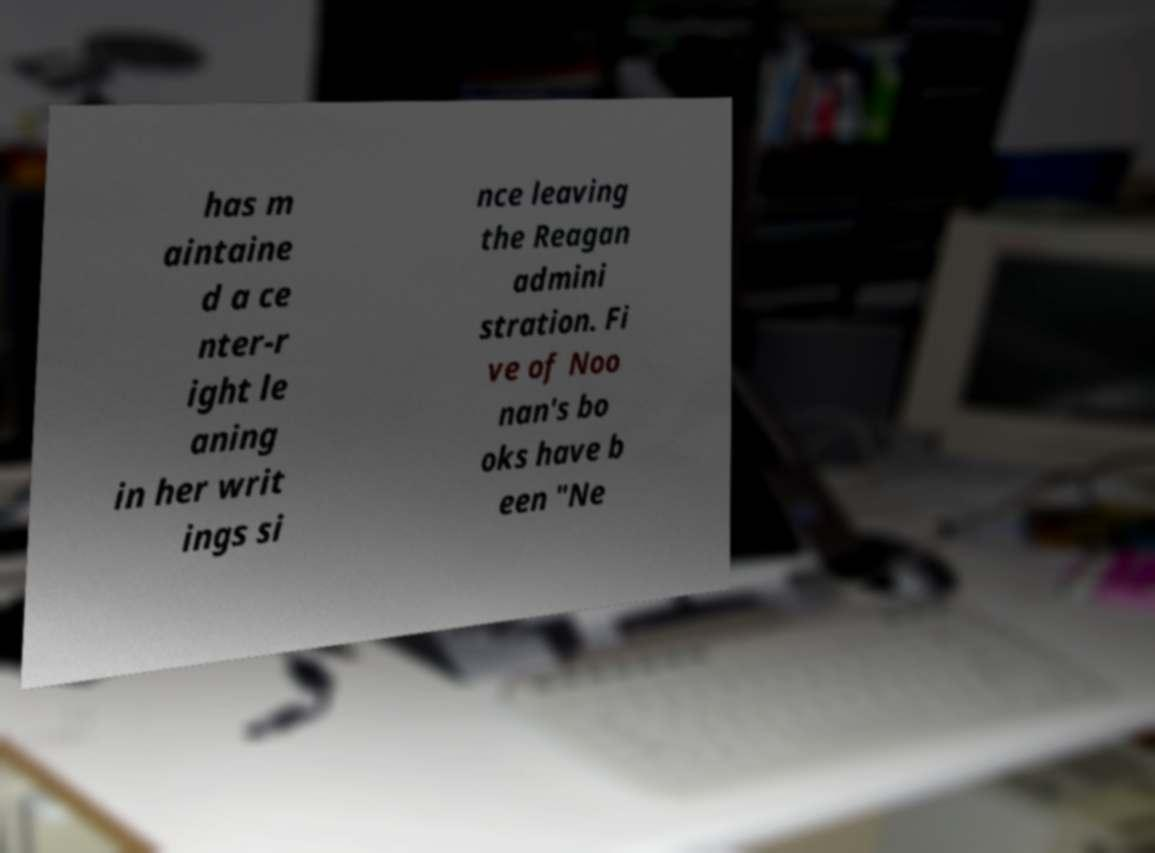Could you assist in decoding the text presented in this image and type it out clearly? has m aintaine d a ce nter-r ight le aning in her writ ings si nce leaving the Reagan admini stration. Fi ve of Noo nan's bo oks have b een "Ne 